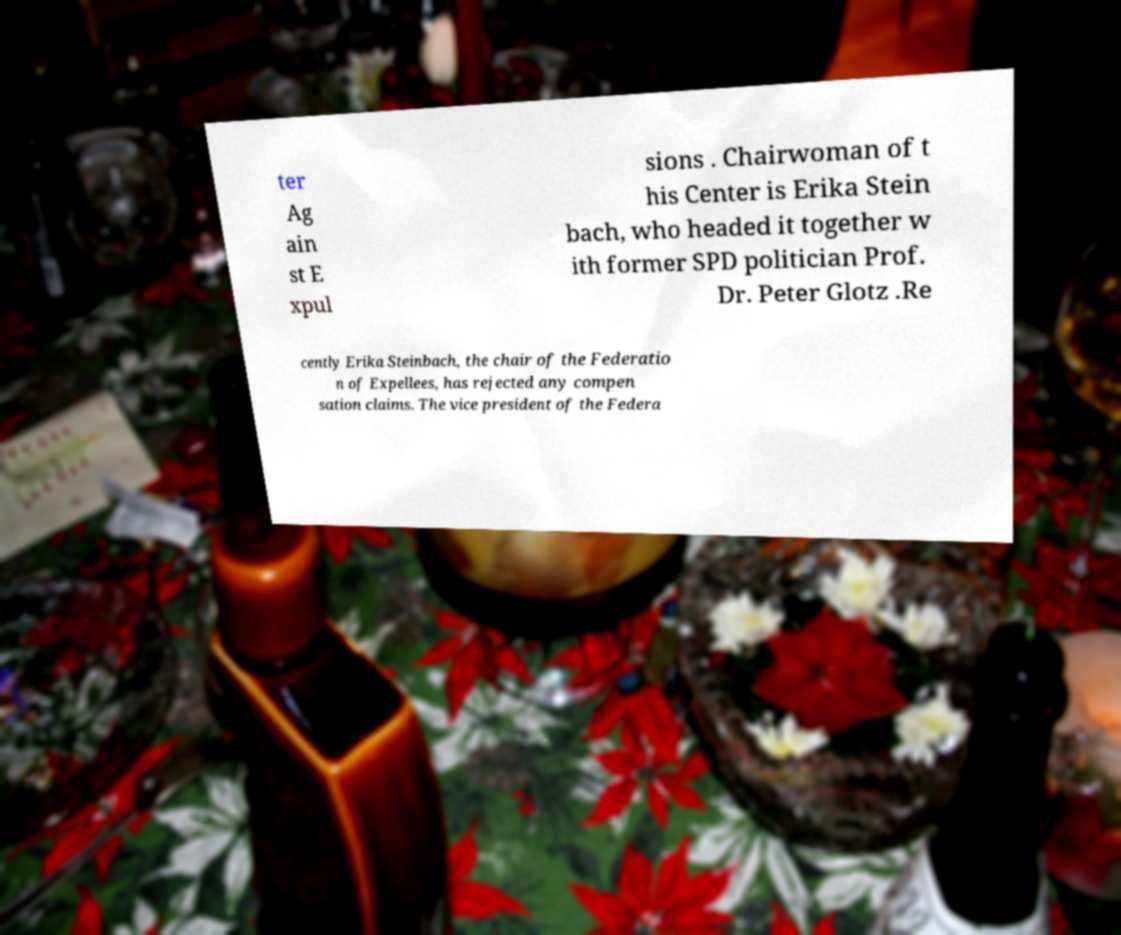Could you extract and type out the text from this image? ter Ag ain st E xpul sions . Chairwoman of t his Center is Erika Stein bach, who headed it together w ith former SPD politician Prof. Dr. Peter Glotz .Re cently Erika Steinbach, the chair of the Federatio n of Expellees, has rejected any compen sation claims. The vice president of the Federa 